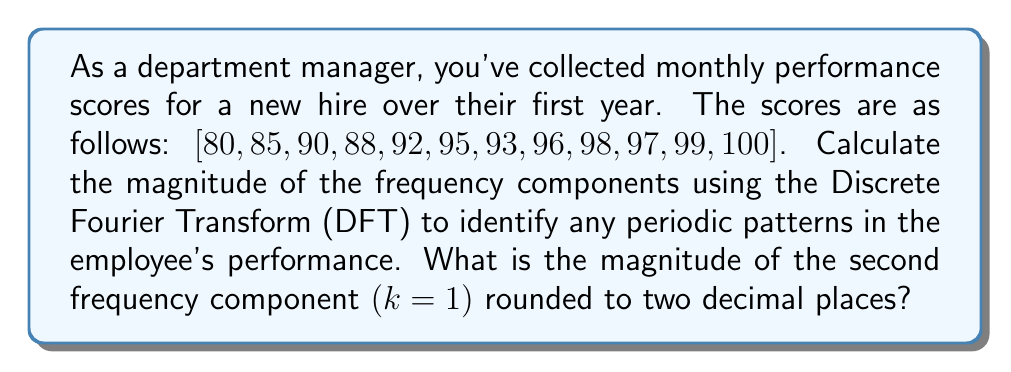Give your solution to this math problem. To solve this problem, we'll follow these steps:

1) The Discrete Fourier Transform (DFT) for a sequence x[n] of length N is given by:

   $$X[k] = \sum_{n=0}^{N-1} x[n] e^{-j2\pi kn/N}$$

   where k = 0, 1, ..., N-1

2) In this case, N = 12 (12 months of data)

3) For k = 1 (second frequency component), we calculate:

   $$X[1] = \sum_{n=0}^{11} x[n] e^{-j2\pi n/12}$$

4) Expand this sum:

   $$X[1] = 80e^{-j2\pi(0)/12} + 85e^{-j2\pi(1)/12} + 90e^{-j2\pi(2)/12} + ... + 100e^{-j2\pi(11)/12}$$

5) Calculate each term:

   $$X[1] = 80 + 85(0.9659 - 0.2588i) + 90(0.8660 - 0.5000i) + 88(0.7071 - 0.7071i) + ...$$

6) Sum all terms:

   $$X[1] = -6.3167 + 8.6603i$$

7) Calculate the magnitude:

   $$|X[1]| = \sqrt{(-6.3167)^2 + (8.6603)^2} = 10.7145$$

8) Round to two decimal places: 10.71
Answer: $10.71$ 